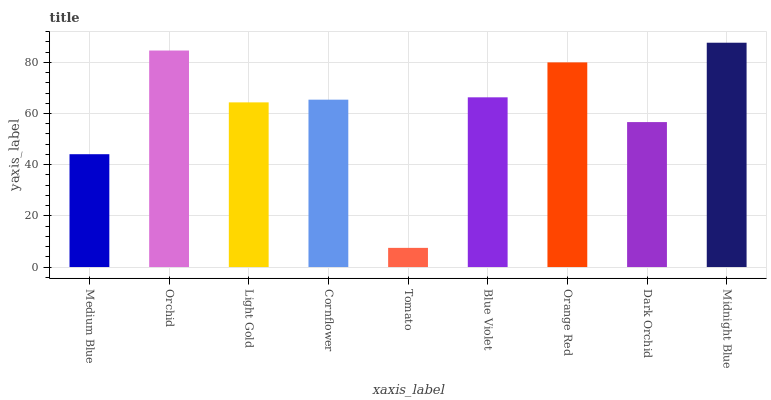Is Tomato the minimum?
Answer yes or no. Yes. Is Midnight Blue the maximum?
Answer yes or no. Yes. Is Orchid the minimum?
Answer yes or no. No. Is Orchid the maximum?
Answer yes or no. No. Is Orchid greater than Medium Blue?
Answer yes or no. Yes. Is Medium Blue less than Orchid?
Answer yes or no. Yes. Is Medium Blue greater than Orchid?
Answer yes or no. No. Is Orchid less than Medium Blue?
Answer yes or no. No. Is Cornflower the high median?
Answer yes or no. Yes. Is Cornflower the low median?
Answer yes or no. Yes. Is Blue Violet the high median?
Answer yes or no. No. Is Medium Blue the low median?
Answer yes or no. No. 